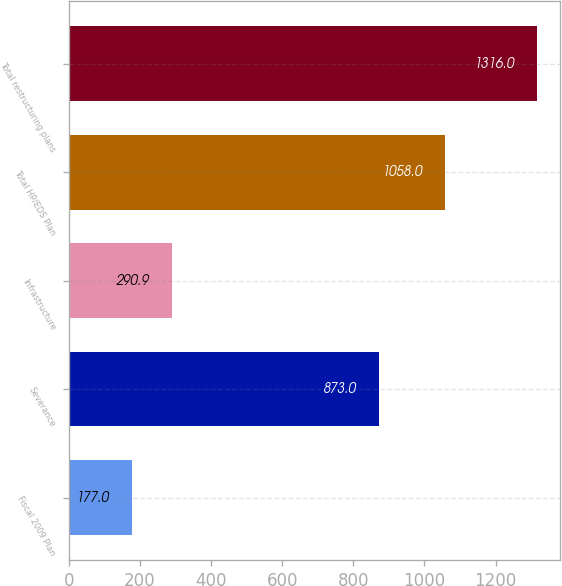Convert chart. <chart><loc_0><loc_0><loc_500><loc_500><bar_chart><fcel>Fiscal 2009 Plan<fcel>Severance<fcel>Infrastructure<fcel>Total HP/EDS Plan<fcel>Total restructuring plans<nl><fcel>177<fcel>873<fcel>290.9<fcel>1058<fcel>1316<nl></chart> 